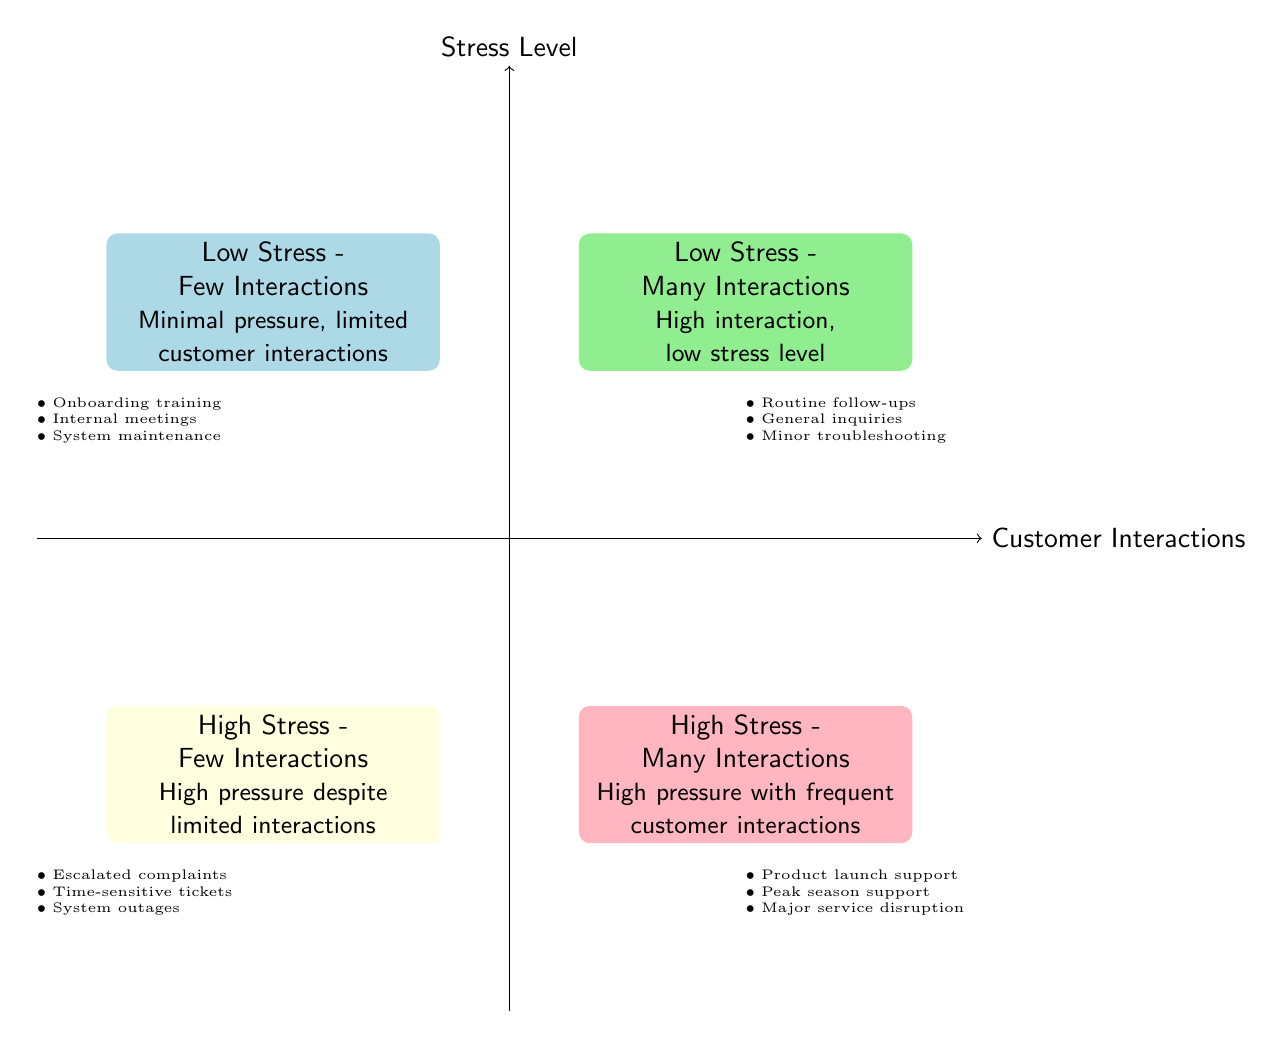What are the four quadrants in the diagram? The diagram includes the quadrants: "Low Stress - Few Interactions," "High Stress - Few Interactions," "Low Stress - Many Interactions," and "High Stress - Many Interactions."
Answer: Low Stress - Few Interactions, High Stress - Few Interactions, Low Stress - Many Interactions, High Stress - Many Interactions Which quadrant has high pressure but few customer interactions? The "High Stress - Few Interactions" quadrant describes a situation of high pressure despite limited interactions.
Answer: High Stress - Few Interactions How many quadrants are there in total? The diagram contains four distinct quadrants that categorize the relationship between stress levels and customer interactions.
Answer: 4 What examples are listed for the "Low Stress - Many Interactions" quadrant? Examples in this quadrant include "Routine follow-ups," "General inquiries handling," and "Minor troubleshooting," indicating typical low-stress tasks with high interactions.
Answer: Routine follow-ups, General inquiries handling, Minor troubleshooting Which quadrant would you expect to find high interaction during a product launch? The "High Stress - Many Interactions" quadrant is where frequent customer interactions are associated with high-pressure situations, like product launch support.
Answer: High Stress - Many Interactions Which quadrant includes handling escalated complaints? The "High Stress - Few Interactions" quadrant is designated for situations involving high pressure but restricted customer interactions, such as handling escalated complaints.
Answer: High Stress - Few Interactions What color represents low stress with few interactions? The "Low Stress - Few Interactions" quadrant is represented by light blue.
Answer: Light blue In which quadrant would you find tasks during peak season support? The "High Stress - Many Interactions" quadrant includes activities like peak season support, indicating both high stress and many customer interactions.
Answer: High Stress - Many Interactions 